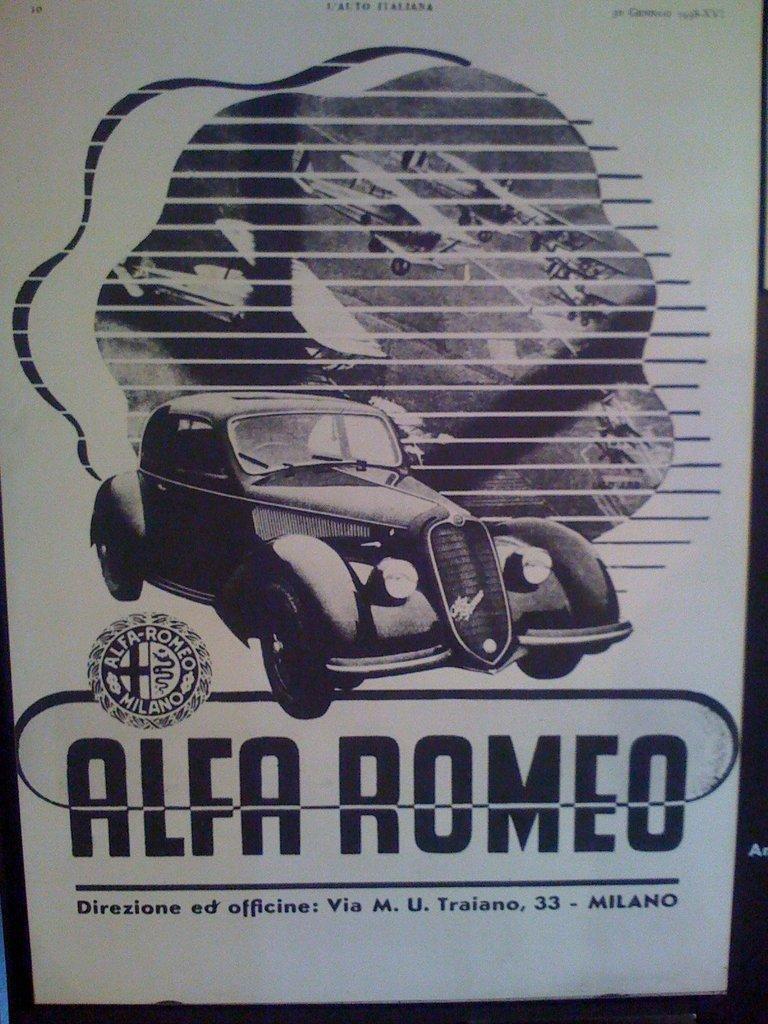Describe this image in one or two sentences. This image looks like a printed image in which I can see a car, text, logo and aircraft's. 